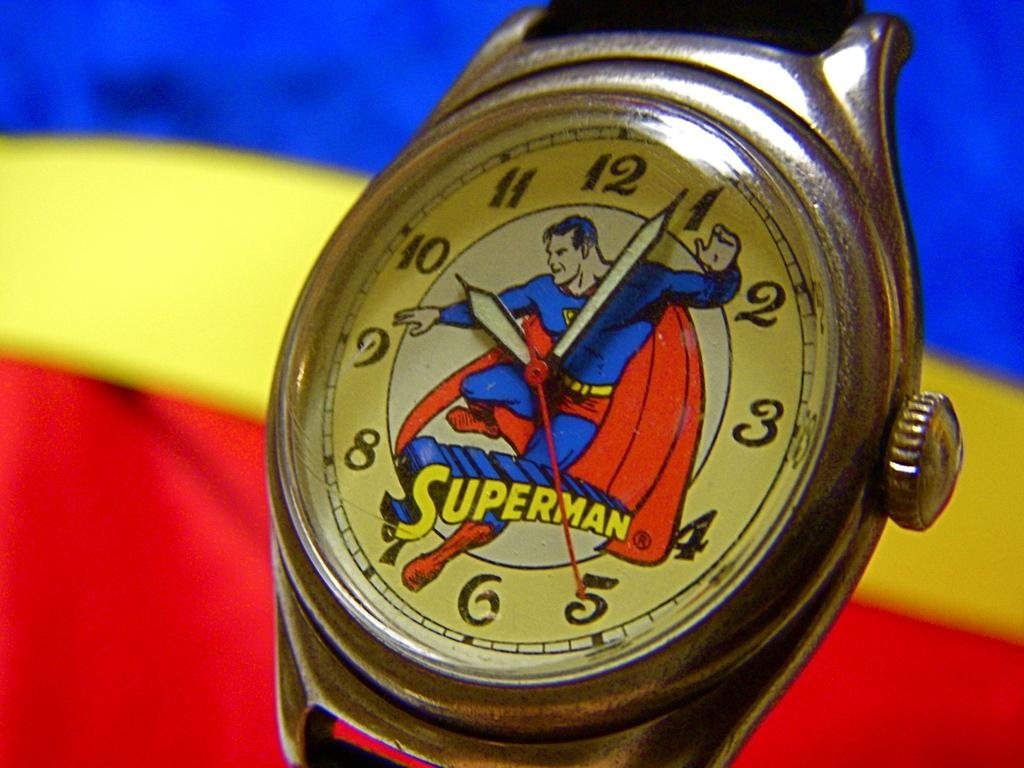<image>
Render a clear and concise summary of the photo. A vintage looking Superman watch showing 10:04 as the time. 